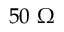Convert formula to latex. <formula><loc_0><loc_0><loc_500><loc_500>5 0 \Omega</formula> 